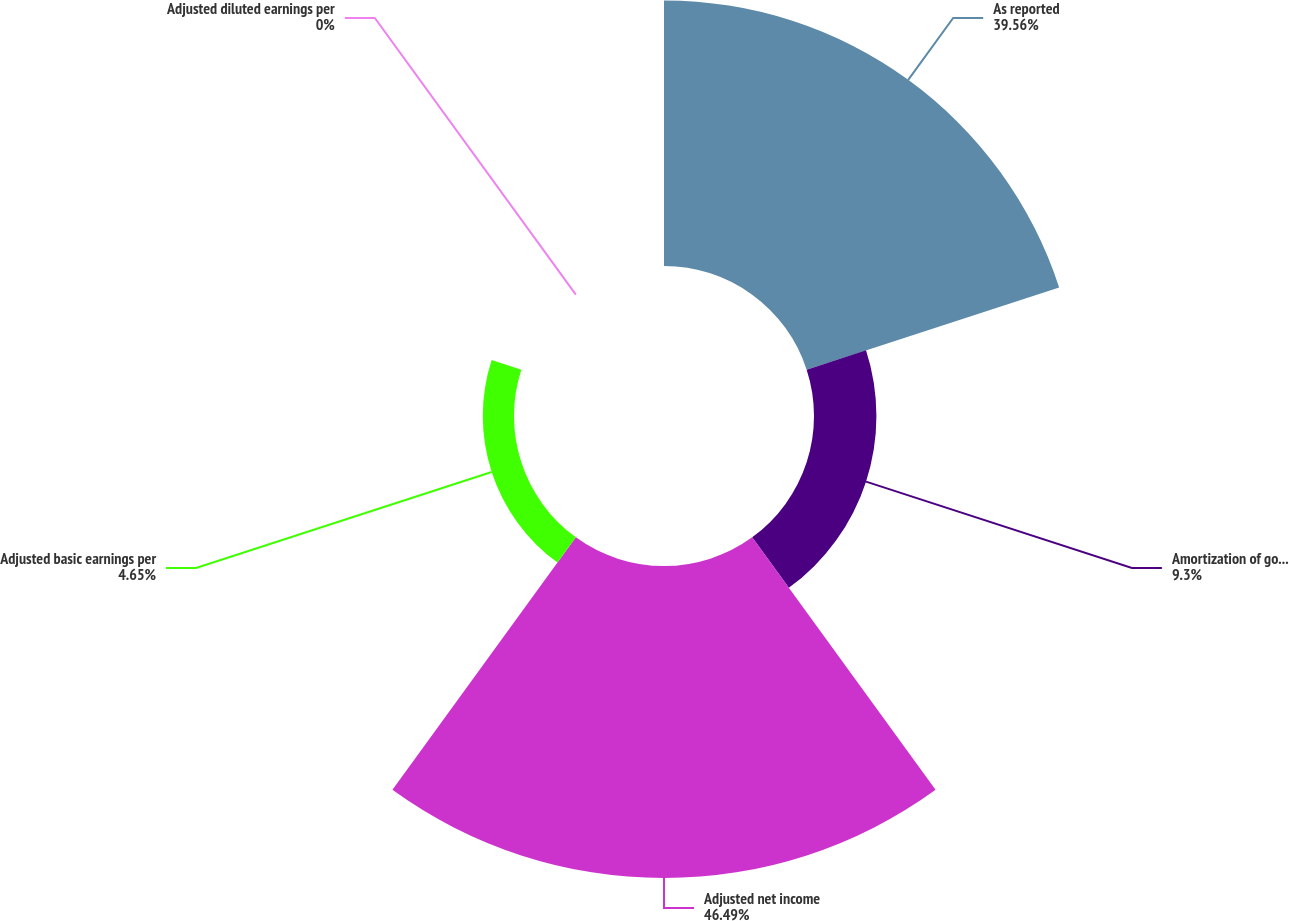<chart> <loc_0><loc_0><loc_500><loc_500><pie_chart><fcel>As reported<fcel>Amortization of goodwill<fcel>Adjusted net income<fcel>Adjusted basic earnings per<fcel>Adjusted diluted earnings per<nl><fcel>39.56%<fcel>9.3%<fcel>46.49%<fcel>4.65%<fcel>0.0%<nl></chart> 